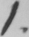Can you read and transcribe this handwriting? 1 . 